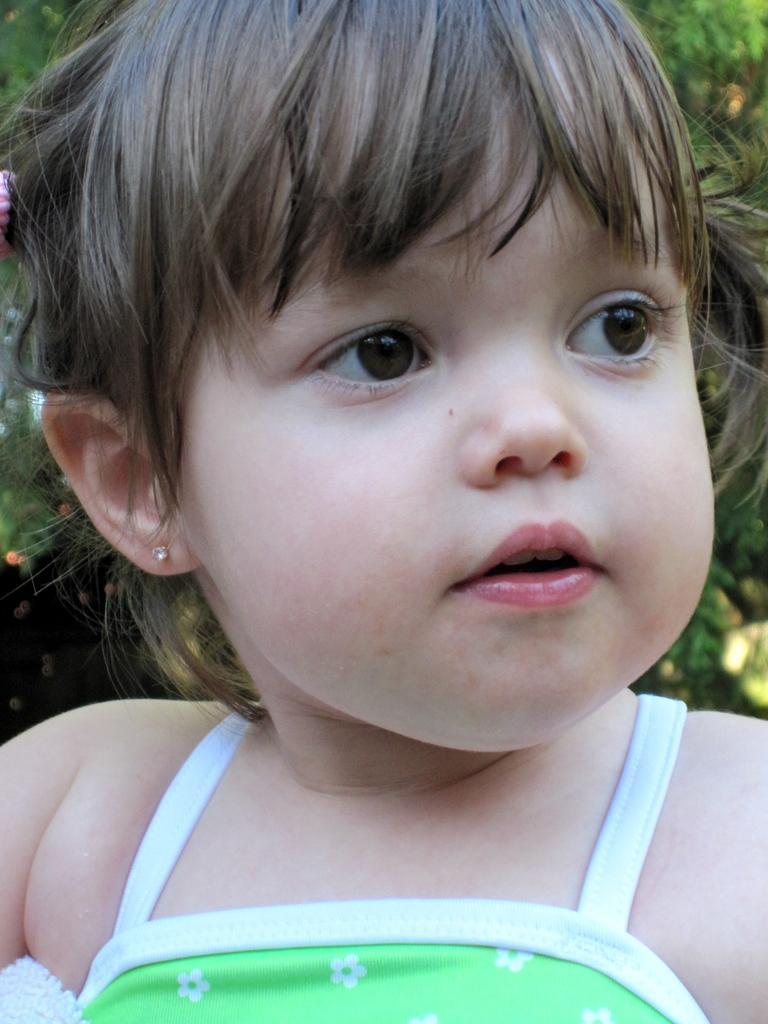How would you summarize this image in a sentence or two? In the image there is a baby. Behind the baby in the background there are trees. 